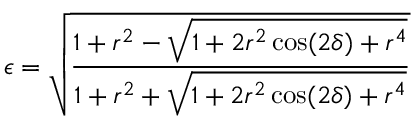<formula> <loc_0><loc_0><loc_500><loc_500>\epsilon = \sqrt { \frac { 1 + r ^ { 2 } - \sqrt { 1 + 2 r ^ { 2 } \cos ( 2 \delta ) + r ^ { 4 } } } { 1 + r ^ { 2 } + \sqrt { 1 + 2 r ^ { 2 } \cos ( 2 \delta ) + r ^ { 4 } } } }</formula> 